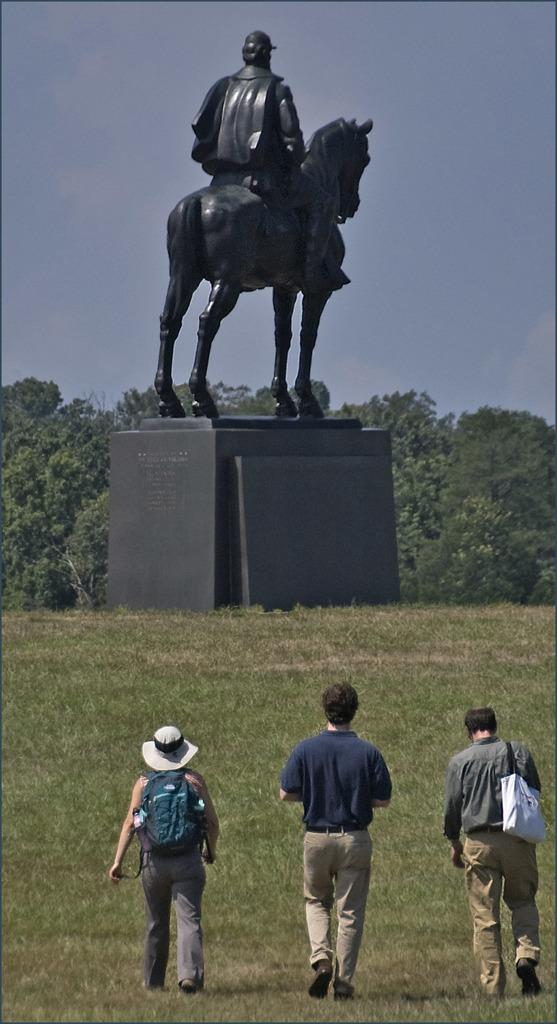How many people are walking in the image? There are three persons walking in the image. What surface are the persons walking on? The persons are walking on the floor. What can be seen in the background of the image? There is a statue and a tree in the background of the image. What is visible above the statue and tree? The sky is visible in the background of the image. How many frogs are hopping around the persons in the image? There are no frogs present in the image; it only features three persons walking. What type of rake is being used by the persons in the image? There is no rake present in the image; the persons are simply walking. 